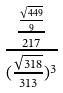Convert formula to latex. <formula><loc_0><loc_0><loc_500><loc_500>\frac { \frac { \frac { \sqrt { 4 4 9 } } { 9 } } { 2 1 7 } } { ( \frac { \sqrt { 3 1 8 } } { 3 1 3 } ) ^ { 3 } }</formula> 